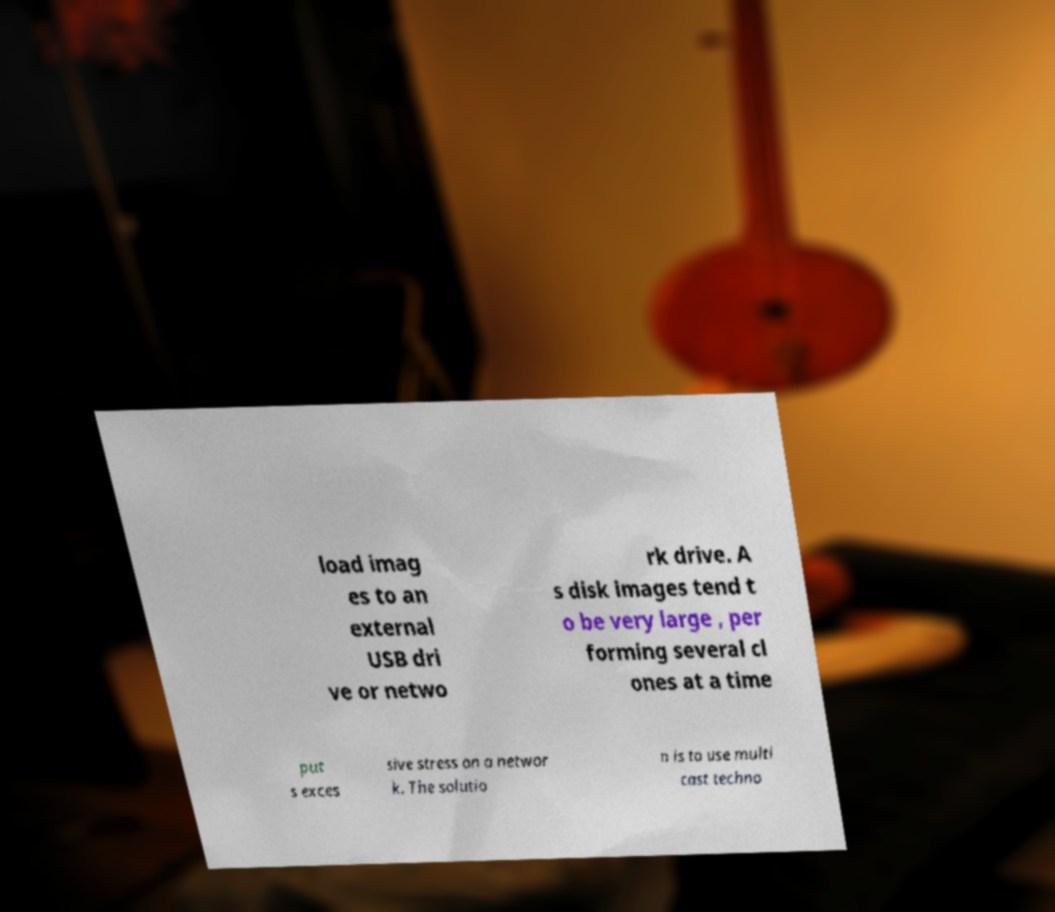For documentation purposes, I need the text within this image transcribed. Could you provide that? load imag es to an external USB dri ve or netwo rk drive. A s disk images tend t o be very large , per forming several cl ones at a time put s exces sive stress on a networ k. The solutio n is to use multi cast techno 